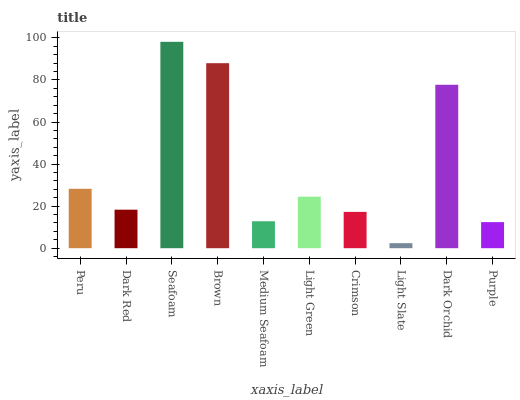Is Light Slate the minimum?
Answer yes or no. Yes. Is Seafoam the maximum?
Answer yes or no. Yes. Is Dark Red the minimum?
Answer yes or no. No. Is Dark Red the maximum?
Answer yes or no. No. Is Peru greater than Dark Red?
Answer yes or no. Yes. Is Dark Red less than Peru?
Answer yes or no. Yes. Is Dark Red greater than Peru?
Answer yes or no. No. Is Peru less than Dark Red?
Answer yes or no. No. Is Light Green the high median?
Answer yes or no. Yes. Is Dark Red the low median?
Answer yes or no. Yes. Is Medium Seafoam the high median?
Answer yes or no. No. Is Brown the low median?
Answer yes or no. No. 